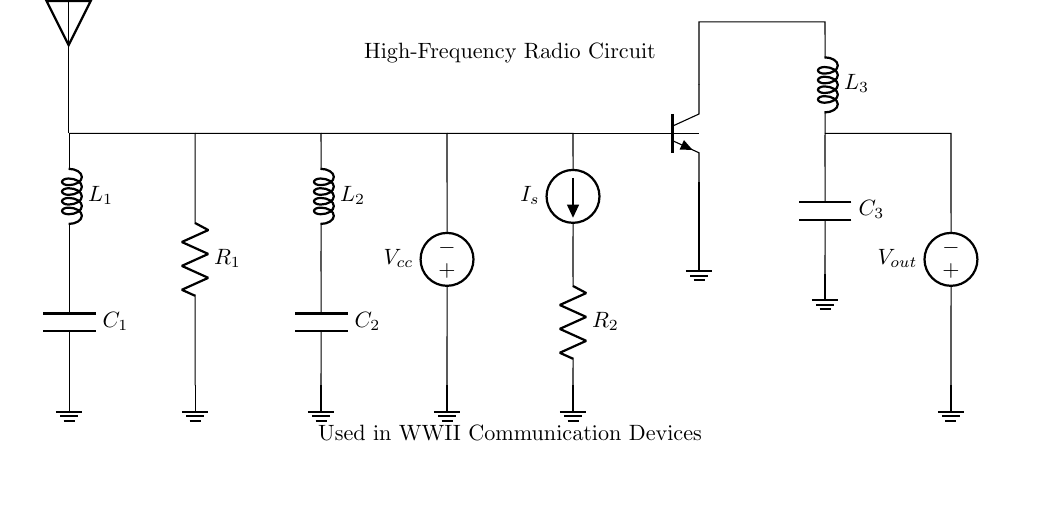What type of circuit is this? This circuit is a high-frequency radio circuit, as indicated by the label at the top that specifically mentions its use in wartime communication devices.
Answer: high-frequency radio circuit What are the components used in this circuit? The components visible in the circuit diagram include antennas, inductors, capacitors, resistors, a voltage source, a current source, and a transistor. These components are essential for the function of radio communication.
Answer: antenna, inductors, capacitors, resistors, voltage source, current source, transistor What is the function of the transistor in this circuit? The transistor serves as a switch or amplifier, allowing the modulation of the radio frequency signal. It is positioned to control the current flow between the collector and emitter, which is essential in radio communications for signal transmission.
Answer: switch or amplifier What is the voltage source labeled as? The voltage source is labeled as Vcc, which typically represents the supply voltage in electronic circuits. This is a standard notation for the positive power supply in such configurations.
Answer: Vcc What is the value of current at the source? The current source is labeled as I_s; however, no numeric value is provided in the circuit diagram to specify its magnitude. The exact value of the current would depend on the design of the circuit and its intended function.
Answer: I_s How do the components L1 and C1 relate in this circuit? Components L1 (inductor) and C1 (capacitor) are in series configuration, forming a resonant circuit that can filter specific frequencies, which is crucial for tuning into radio signals. They work together to determine the frequency response of the circuit.
Answer: resonant circuit Which components are involved in the output stage of the circuit? The output stage consists of the transistor Q1 and the associated components L3 and C3. These components interact to generate and shape the output signal for transmission.
Answer: transistor, L3, C3 